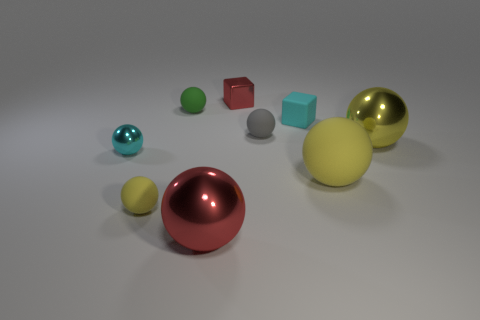What size is the sphere that is the same color as the metal cube?
Ensure brevity in your answer.  Large. Are there fewer red rubber things than large metal spheres?
Offer a very short reply. Yes. Are there any small shiny spheres that are in front of the object in front of the yellow sphere that is to the left of the gray matte thing?
Make the answer very short. No. What number of matte things are small objects or big brown objects?
Your response must be concise. 4. Does the metallic cube have the same color as the big matte thing?
Make the answer very short. No. There is a tiny red metal block; how many tiny cyan balls are to the right of it?
Provide a succinct answer. 0. How many rubber things are both behind the large yellow metal sphere and on the left side of the cyan cube?
Offer a very short reply. 2. There is a yellow object that is the same material as the small red cube; what is its shape?
Make the answer very short. Sphere. Is the size of the yellow matte thing right of the green thing the same as the cyan thing that is in front of the large yellow metallic object?
Provide a succinct answer. No. There is a tiny metal object that is in front of the small green matte object; what color is it?
Ensure brevity in your answer.  Cyan. 